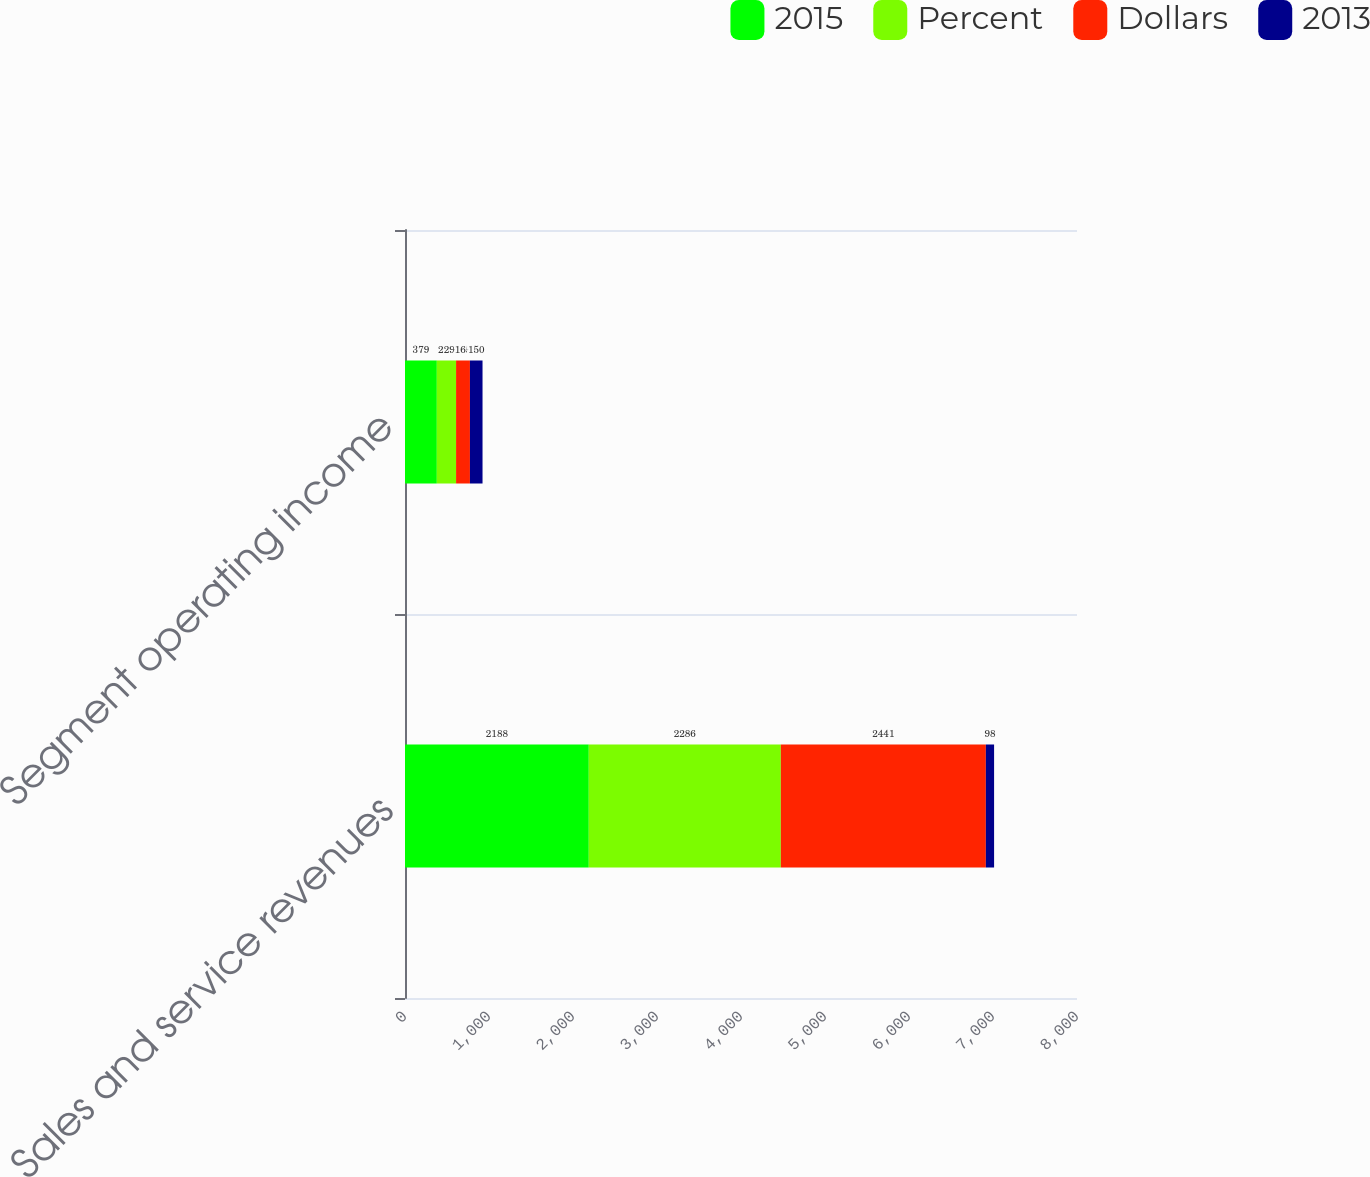Convert chart to OTSL. <chart><loc_0><loc_0><loc_500><loc_500><stacked_bar_chart><ecel><fcel>Sales and service revenues<fcel>Segment operating income<nl><fcel>2015<fcel>2188<fcel>379<nl><fcel>Percent<fcel>2286<fcel>229<nl><fcel>Dollars<fcel>2441<fcel>165<nl><fcel>2013<fcel>98<fcel>150<nl></chart> 